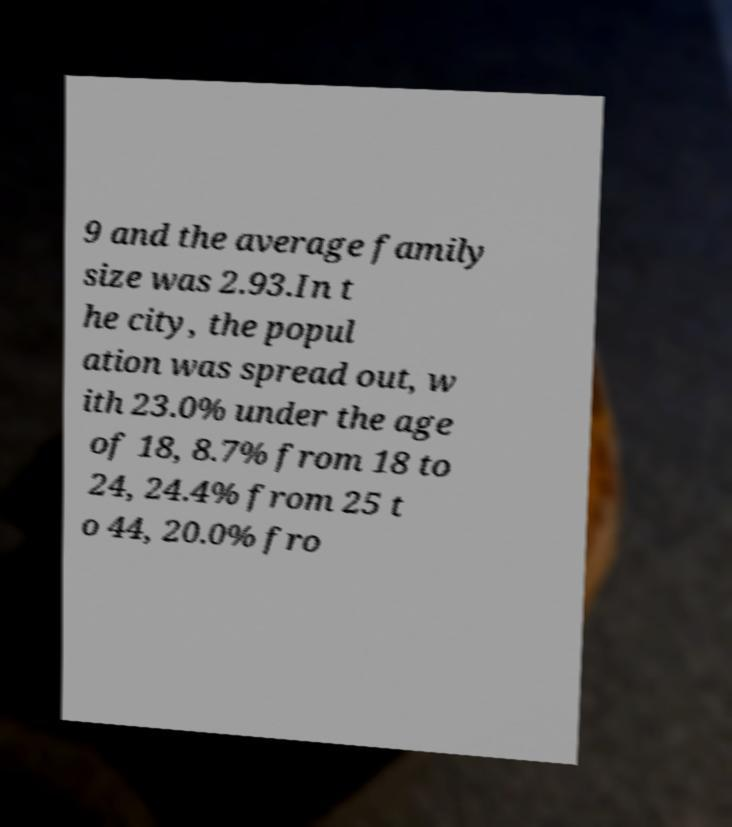For documentation purposes, I need the text within this image transcribed. Could you provide that? 9 and the average family size was 2.93.In t he city, the popul ation was spread out, w ith 23.0% under the age of 18, 8.7% from 18 to 24, 24.4% from 25 t o 44, 20.0% fro 